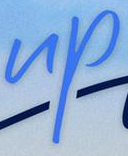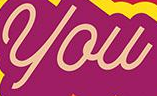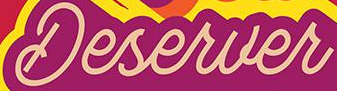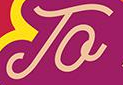What text is displayed in these images sequentially, separated by a semicolon? up; you; Deserver; To 